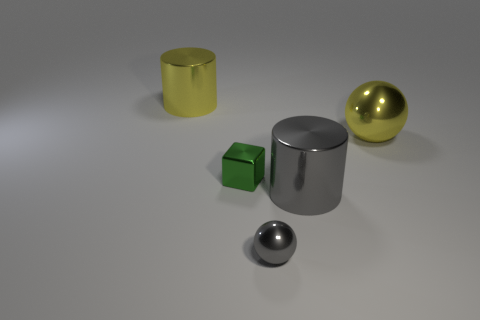Is the number of small cubes less than the number of tiny gray matte balls?
Your answer should be very brief. No. What number of metal things are the same color as the tiny shiny ball?
Keep it short and to the point. 1. There is a shiny cylinder that is to the right of the big yellow shiny cylinder; is its color the same as the tiny sphere?
Your response must be concise. Yes. There is a big thing that is on the right side of the large gray metallic cylinder; what is its shape?
Provide a short and direct response. Sphere. Are there any gray things that are on the right side of the metallic sphere to the left of the big yellow shiny sphere?
Provide a succinct answer. Yes. What number of other big cylinders are made of the same material as the gray cylinder?
Your answer should be compact. 1. There is a sphere that is right of the gray metallic thing that is in front of the metal cylinder that is in front of the big metal ball; what size is it?
Offer a terse response. Large. What number of yellow shiny cylinders are left of the green metal cube?
Give a very brief answer. 1. Is the number of tiny objects greater than the number of big metallic objects?
Provide a short and direct response. No. There is a cylinder that is the same color as the large shiny ball; what size is it?
Your answer should be compact. Large. 